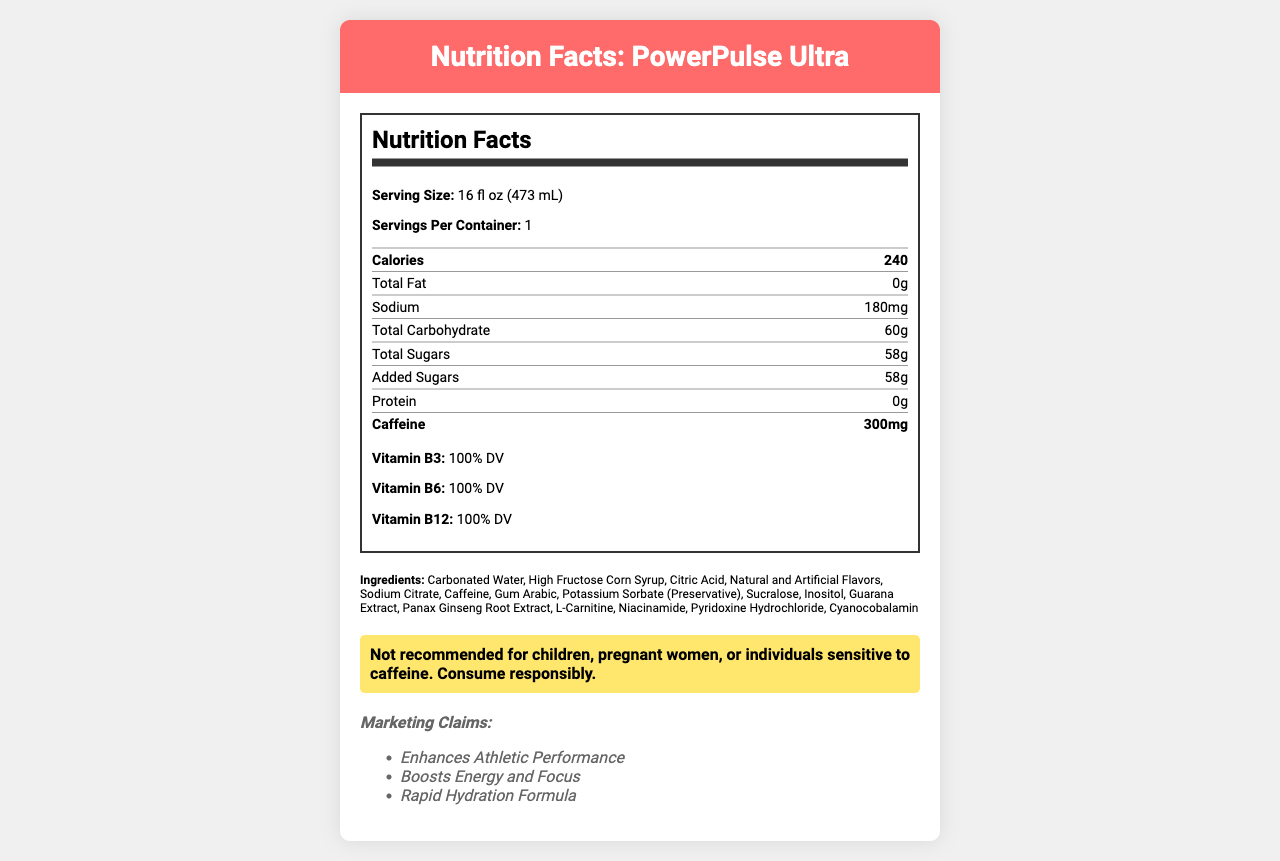what is the product name? The product name is explicitly stated at the top of the Nutrition Facts label.
Answer: PowerPulse Ultra what is the serving size for the energy drink? The serving size for the energy drink is mentioned right after the heading "Serving Size".
Answer: 16 fl oz (473 mL) how many servings are there per container? The label specifies that there is 1 serving per container.
Answer: 1 how many calories are there per serving? The label shows "Calories: 240" under the nutritional information section.
Answer: 240 what is the amount of caffeine in one serving? The amount of caffeine per serving is highlighted prominently in the nutritional information section of the document.
Answer: 300mg which two vitamins are present at 100% DV? A. Vitamin B1 and Vitamin B2 B. Vitamin B3 and Vitamin B6 C. Vitamin A and Vitamin C D. Vitamin D and Vitamin K The nutritional information states that Vitamin B3 and Vitamin B6 are both present at 100% Daily Value (DV).
Answer: B how much total sugar does the drink contain per serving? The document lists the amount of total sugars as 58g under the carbohydrate section.
Answer: 58g what is the amount of added sugars in the drink? The label specifies that added sugars also amount to 58g, which is noticeable under the carbohydrate information.
Answer: 58g True or False: The drink contains protein. The nutritional information shows "Protein: 0g," indicating that there is no protein in the drink.
Answer: False summary of the entire document This summary captures the main aspects of the document, including nutritional data, ingredients, warnings, marketing claims, and health considerations.
Answer: PowerPulse Ultra is an energy drink marketed towards athletes and fitness enthusiasts aged 18-35. Each 16 fl oz serving contains 240 calories, 0g of fat, 180mg of sodium, 60g of carbohydrates (including 58g of total and added sugars), and 0g of protein. Additionally, it contains a high caffeine content at 300mg per serving, and 100% DV of Vitamin B3, B6, and B12. Ingredients include carbonated water, high fructose corn syrup, and various additives like caffeine, guarana extract, and Panax ginseng root extract. Warnings suggest responsible consumption, especially for sensitive individuals. Marketed claims include enhancing athletic performance and boosting energy and focus. Potential health concerns include excessive caffeine intake and high sugar content. what are some potential health concerns associated with this drink? The document lists these potential health concerns explicitly.
Answer: Excessive caffeine intake, high sugar content, potential for caffeine addiction, increased risk of dental erosion, possible interactions with certain medications what is the warning statement provided on the label? The warning statement is directly listed under the significant nutritional content.
Answer: Not recommended for children, pregnant women, or individuals sensitive to caffeine. Consume responsibly. who manufactures this energy drink? This information is located towards the end of the document with the manufacturing details.
Answer: ExtremeSports Beverages, Inc. how many calories come from carbohydrates? Given that carbohydrates provide 4 calories per gram and there are 60g of carbohydrates in the drink, the calculation is 60g * 4 = 240 calories from carbohydrates.
Answer: 240 provide one of the comparable products mentioned on the label The document lists Red Bull as one of the comparable products.
Answer: Red Bull which ingredient is used as a sweetener in this drink? A. Aspartame B. Sucralose C. Stevia D. Monk Fruit The list of ingredients includes sucralose, which is a commonly used artificial sweetener.
Answer: B Is there enough information to determine the cost of the energy drink? The document does not provide any data related to the price or cost of the energy drink.
Answer: No 